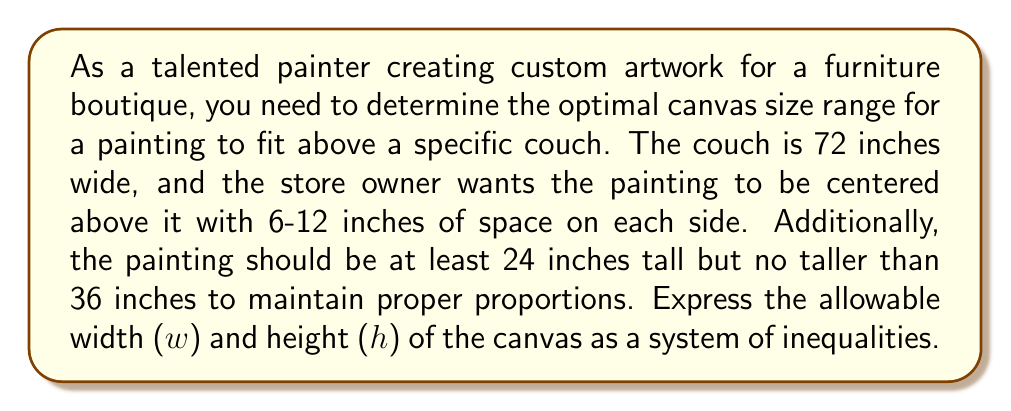Show me your answer to this math problem. Let's break this problem down step by step:

1. Width constraints:
   - The couch is 72 inches wide
   - There should be 6-12 inches of space on each side of the painting
   
   We can express this as:
   $$72 - 2(12) \leq w \leq 72 - 2(6)$$
   $$48 \leq w \leq 60$$

2. Height constraints:
   - The painting should be at least 24 inches tall
   - The painting should be no taller than 36 inches
   
   We can express this as:
   $$24 \leq h \leq 36$$

3. Combining the width and height inequalities, we get a system of inequalities:

   $$\begin{cases}
   48 \leq w \leq 60 \\
   24 \leq h \leq 36
   \end{cases}$$

This system of inequalities represents the allowable dimensions for the canvas, ensuring it fits properly above the couch while maintaining the desired spacing and proportions.
Answer: The optimal canvas size range can be expressed as the following system of inequalities:

$$\begin{cases}
48 \leq w \leq 60 \\
24 \leq h \leq 36
\end{cases}$$

Where $w$ represents the width of the canvas in inches and $h$ represents the height of the canvas in inches. 